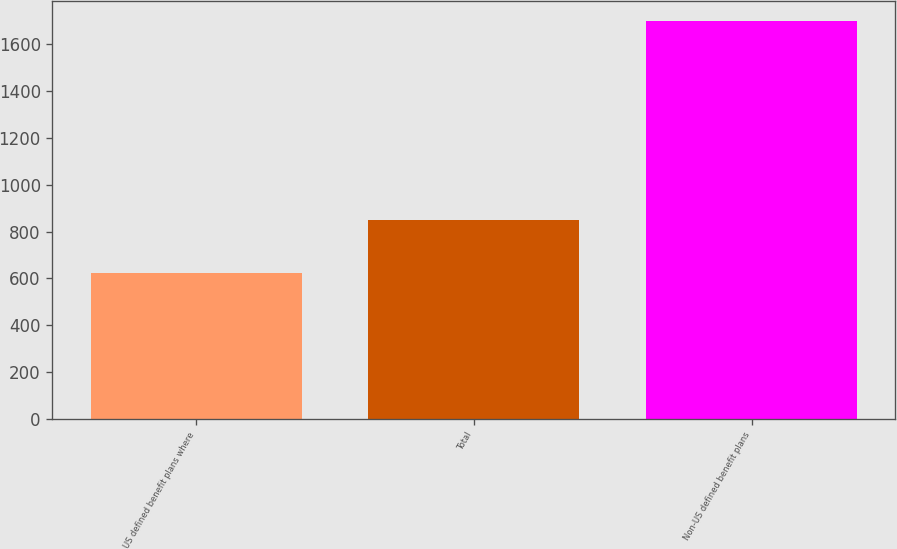<chart> <loc_0><loc_0><loc_500><loc_500><bar_chart><fcel>US defined benefit plans where<fcel>Total<fcel>Non-US defined benefit plans<nl><fcel>624<fcel>851.2<fcel>1699<nl></chart> 